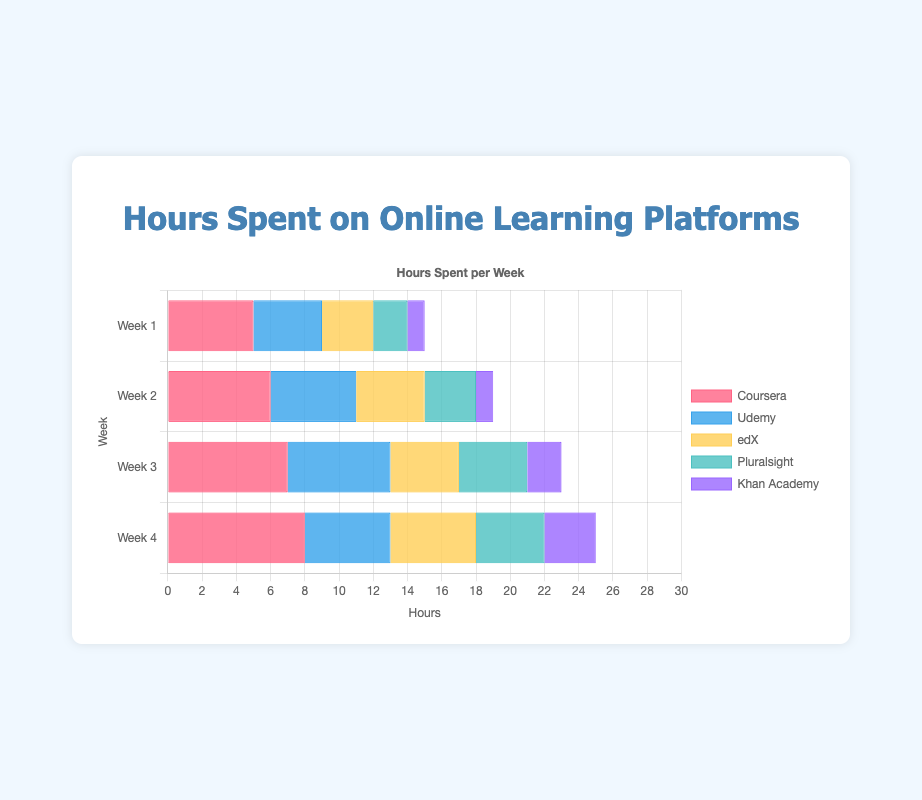Which platform had the highest number of hours in Week 1? In Week 1, we compare the heights of the bars for each platform: Coursera (5) > Udemy (4) > edX (3) > Pluralsight (2) > Khan Academy (1). Therefore, Coursera had the highest number of hours.
Answer: Coursera What is the total number of hours spent on Coursera over the four weeks? Sum the hours for Coursera across all four weeks: 5 (Week 1) + 6 (Week 2) + 7 (Week 3) + 8 (Week 4) = 26 hours.
Answer: 26 Which platform showed the least growth in hours from Week 1 to Week 4? Calculate the difference between Week 1 and Week 4 for each platform: Coursera (8 - 5 = 3), Udemy (5 - 4 = 1), edX (5 - 3 = 2), Pluralsight (4 - 2 = 2), Khan Academy (3 - 1 = 2). Udemy shows the smallest growth (1 hour).
Answer: Udemy What is the average number of hours spent on all platforms during Week 3? Sum the hours for all platforms in Week 3 and divide by the number of platforms: (7 + 6 + 4 + 4 + 2) / 5 = 23 / 5 = 4.6 hours.
Answer: 4.6 Which week had the highest total number of hours spent across all platforms? Sum the hours for each week across all platforms: Week 1 (5+4+3+2+1=15), Week 2 (6+5+4+3+1=19), Week 3 (7+6+4+4+2=23), Week 4 (8+5+5+4+3=25). Week 4 has the highest total hours (25).
Answer: Week 4 How did the hours spent on edX compare to Pluralsight in Week 2? In Week 2, the number of hours spent on edX is 4 and on Pluralsight is 3. edX had more hours than Pluralsight in Week 2.
Answer: edX had more What is the reduction in hours for Udemy from Week 3 to Week 4? The hours for Udemy in Week 3 are 6 and in Week 4 are 5. The reduction is 6 - 5 = 1 hour.
Answer: 1 Which platform's usage remained unchanged from Week 3 to Week 4? Compare hours between Week 3 and Week 4 for each platform: Coursera (7 to 8), Udemy (6 to 5), edX (4 to 5), Pluralsight (4 to 4), Khan Academy (2 to 3). Only Pluralsight remained unchanged.
Answer: Pluralsight What is the difference in total hours spent between Coursera and Khan Academy over four weeks? Calculate the total hours for Coursera (5+6+7+8=26) and Khan Academy (1+1+2+3=7). The difference is 26 - 7 = 19 hours.
Answer: 19 How many more hours were spent on Coursera than Udemy in Week 4? The hours spent in Week 4 for Coursera are 8 and for Udemy are 5. The difference is 8 - 5 = 3 hours.
Answer: 3 